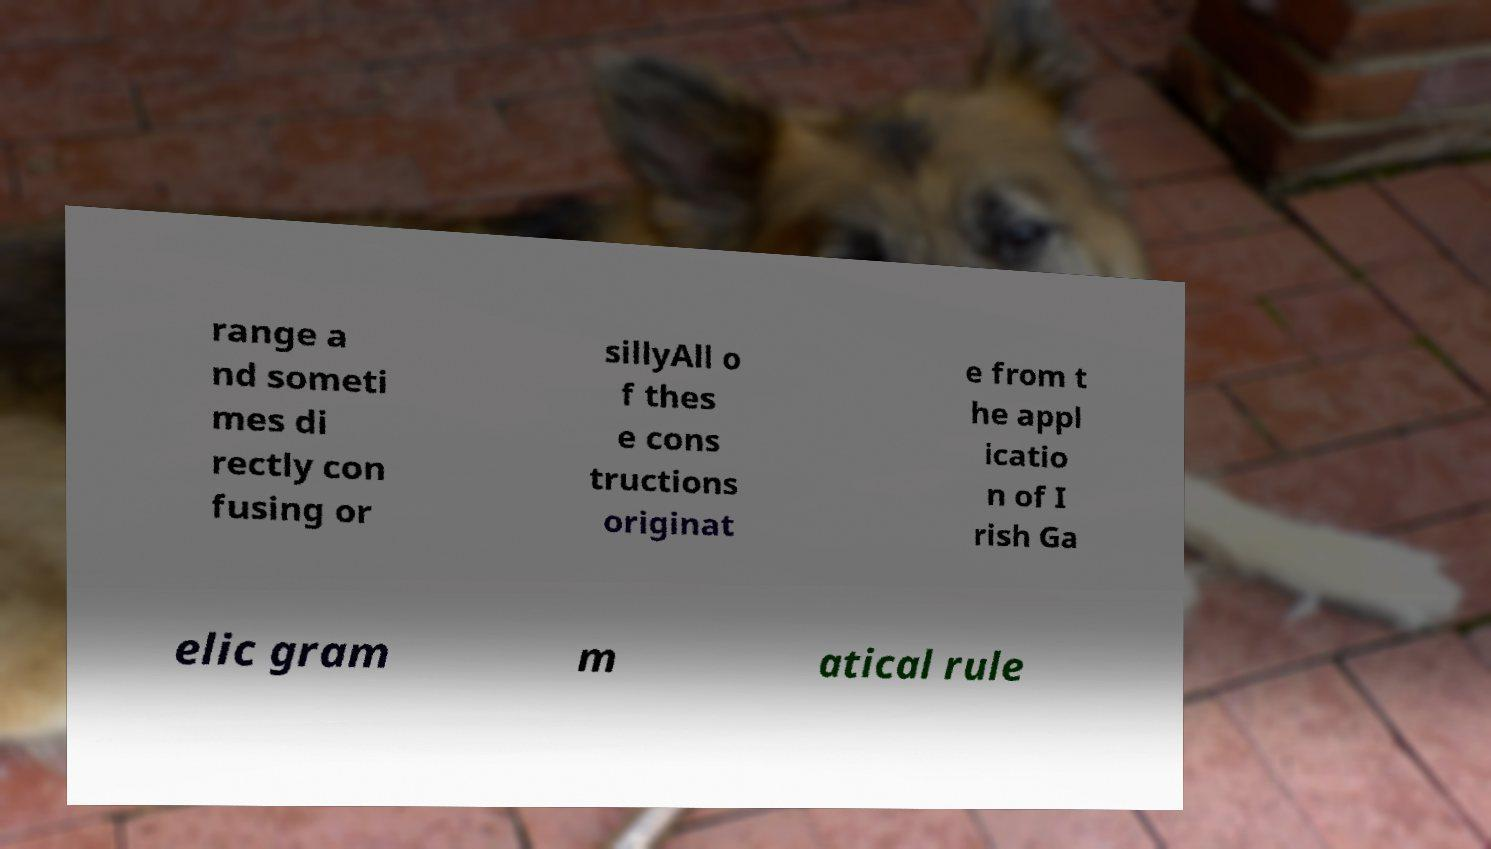Could you extract and type out the text from this image? range a nd someti mes di rectly con fusing or sillyAll o f thes e cons tructions originat e from t he appl icatio n of I rish Ga elic gram m atical rule 